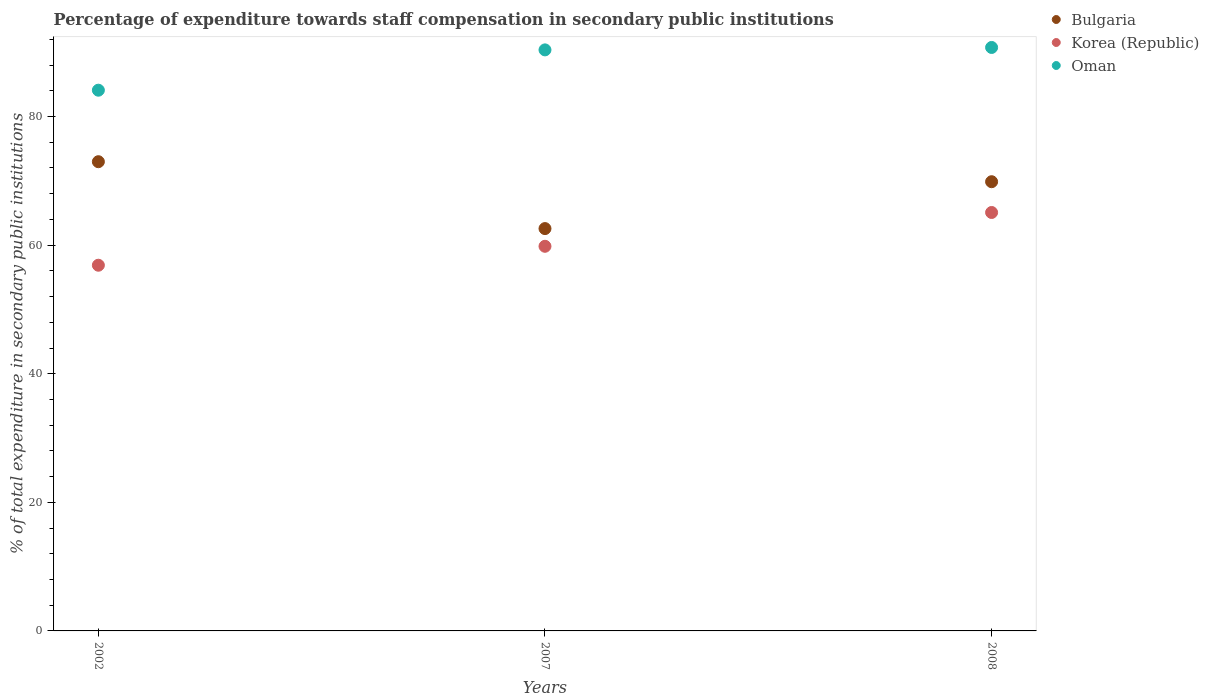How many different coloured dotlines are there?
Your answer should be compact. 3. Is the number of dotlines equal to the number of legend labels?
Provide a succinct answer. Yes. What is the percentage of expenditure towards staff compensation in Korea (Republic) in 2007?
Ensure brevity in your answer.  59.82. Across all years, what is the maximum percentage of expenditure towards staff compensation in Korea (Republic)?
Ensure brevity in your answer.  65.08. Across all years, what is the minimum percentage of expenditure towards staff compensation in Oman?
Make the answer very short. 84.1. What is the total percentage of expenditure towards staff compensation in Bulgaria in the graph?
Provide a short and direct response. 205.41. What is the difference between the percentage of expenditure towards staff compensation in Oman in 2002 and that in 2008?
Keep it short and to the point. -6.65. What is the difference between the percentage of expenditure towards staff compensation in Bulgaria in 2002 and the percentage of expenditure towards staff compensation in Oman in 2007?
Ensure brevity in your answer.  -17.39. What is the average percentage of expenditure towards staff compensation in Oman per year?
Offer a very short reply. 88.4. In the year 2008, what is the difference between the percentage of expenditure towards staff compensation in Oman and percentage of expenditure towards staff compensation in Korea (Republic)?
Your answer should be very brief. 25.67. What is the ratio of the percentage of expenditure towards staff compensation in Korea (Republic) in 2007 to that in 2008?
Ensure brevity in your answer.  0.92. What is the difference between the highest and the second highest percentage of expenditure towards staff compensation in Oman?
Provide a short and direct response. 0.38. What is the difference between the highest and the lowest percentage of expenditure towards staff compensation in Bulgaria?
Your answer should be compact. 10.4. Does the percentage of expenditure towards staff compensation in Bulgaria monotonically increase over the years?
Ensure brevity in your answer.  No. Is the percentage of expenditure towards staff compensation in Bulgaria strictly less than the percentage of expenditure towards staff compensation in Korea (Republic) over the years?
Keep it short and to the point. No. How many years are there in the graph?
Your answer should be very brief. 3. Are the values on the major ticks of Y-axis written in scientific E-notation?
Your answer should be very brief. No. How are the legend labels stacked?
Give a very brief answer. Vertical. What is the title of the graph?
Provide a succinct answer. Percentage of expenditure towards staff compensation in secondary public institutions. Does "Iran" appear as one of the legend labels in the graph?
Provide a succinct answer. No. What is the label or title of the X-axis?
Ensure brevity in your answer.  Years. What is the label or title of the Y-axis?
Offer a very short reply. % of total expenditure in secondary public institutions. What is the % of total expenditure in secondary public institutions of Bulgaria in 2002?
Offer a terse response. 72.97. What is the % of total expenditure in secondary public institutions in Korea (Republic) in 2002?
Ensure brevity in your answer.  56.87. What is the % of total expenditure in secondary public institutions in Oman in 2002?
Provide a succinct answer. 84.1. What is the % of total expenditure in secondary public institutions in Bulgaria in 2007?
Provide a short and direct response. 62.57. What is the % of total expenditure in secondary public institutions in Korea (Republic) in 2007?
Provide a short and direct response. 59.82. What is the % of total expenditure in secondary public institutions in Oman in 2007?
Your answer should be compact. 90.37. What is the % of total expenditure in secondary public institutions in Bulgaria in 2008?
Provide a short and direct response. 69.86. What is the % of total expenditure in secondary public institutions in Korea (Republic) in 2008?
Make the answer very short. 65.08. What is the % of total expenditure in secondary public institutions in Oman in 2008?
Give a very brief answer. 90.74. Across all years, what is the maximum % of total expenditure in secondary public institutions of Bulgaria?
Make the answer very short. 72.97. Across all years, what is the maximum % of total expenditure in secondary public institutions in Korea (Republic)?
Ensure brevity in your answer.  65.08. Across all years, what is the maximum % of total expenditure in secondary public institutions of Oman?
Your answer should be compact. 90.74. Across all years, what is the minimum % of total expenditure in secondary public institutions in Bulgaria?
Offer a terse response. 62.57. Across all years, what is the minimum % of total expenditure in secondary public institutions of Korea (Republic)?
Offer a very short reply. 56.87. Across all years, what is the minimum % of total expenditure in secondary public institutions in Oman?
Provide a succinct answer. 84.1. What is the total % of total expenditure in secondary public institutions of Bulgaria in the graph?
Your response must be concise. 205.41. What is the total % of total expenditure in secondary public institutions in Korea (Republic) in the graph?
Make the answer very short. 181.77. What is the total % of total expenditure in secondary public institutions of Oman in the graph?
Provide a short and direct response. 265.2. What is the difference between the % of total expenditure in secondary public institutions in Bulgaria in 2002 and that in 2007?
Offer a very short reply. 10.4. What is the difference between the % of total expenditure in secondary public institutions in Korea (Republic) in 2002 and that in 2007?
Offer a terse response. -2.94. What is the difference between the % of total expenditure in secondary public institutions of Oman in 2002 and that in 2007?
Offer a very short reply. -6.27. What is the difference between the % of total expenditure in secondary public institutions in Bulgaria in 2002 and that in 2008?
Make the answer very short. 3.11. What is the difference between the % of total expenditure in secondary public institutions of Korea (Republic) in 2002 and that in 2008?
Provide a succinct answer. -8.2. What is the difference between the % of total expenditure in secondary public institutions in Oman in 2002 and that in 2008?
Give a very brief answer. -6.65. What is the difference between the % of total expenditure in secondary public institutions in Bulgaria in 2007 and that in 2008?
Give a very brief answer. -7.29. What is the difference between the % of total expenditure in secondary public institutions of Korea (Republic) in 2007 and that in 2008?
Keep it short and to the point. -5.26. What is the difference between the % of total expenditure in secondary public institutions in Oman in 2007 and that in 2008?
Your answer should be compact. -0.38. What is the difference between the % of total expenditure in secondary public institutions in Bulgaria in 2002 and the % of total expenditure in secondary public institutions in Korea (Republic) in 2007?
Give a very brief answer. 13.16. What is the difference between the % of total expenditure in secondary public institutions in Bulgaria in 2002 and the % of total expenditure in secondary public institutions in Oman in 2007?
Make the answer very short. -17.39. What is the difference between the % of total expenditure in secondary public institutions in Korea (Republic) in 2002 and the % of total expenditure in secondary public institutions in Oman in 2007?
Your response must be concise. -33.49. What is the difference between the % of total expenditure in secondary public institutions in Bulgaria in 2002 and the % of total expenditure in secondary public institutions in Korea (Republic) in 2008?
Make the answer very short. 7.9. What is the difference between the % of total expenditure in secondary public institutions in Bulgaria in 2002 and the % of total expenditure in secondary public institutions in Oman in 2008?
Keep it short and to the point. -17.77. What is the difference between the % of total expenditure in secondary public institutions of Korea (Republic) in 2002 and the % of total expenditure in secondary public institutions of Oman in 2008?
Your response must be concise. -33.87. What is the difference between the % of total expenditure in secondary public institutions of Bulgaria in 2007 and the % of total expenditure in secondary public institutions of Korea (Republic) in 2008?
Your answer should be very brief. -2.5. What is the difference between the % of total expenditure in secondary public institutions of Bulgaria in 2007 and the % of total expenditure in secondary public institutions of Oman in 2008?
Offer a terse response. -28.17. What is the difference between the % of total expenditure in secondary public institutions in Korea (Republic) in 2007 and the % of total expenditure in secondary public institutions in Oman in 2008?
Your response must be concise. -30.92. What is the average % of total expenditure in secondary public institutions in Bulgaria per year?
Offer a very short reply. 68.47. What is the average % of total expenditure in secondary public institutions in Korea (Republic) per year?
Give a very brief answer. 60.59. What is the average % of total expenditure in secondary public institutions in Oman per year?
Ensure brevity in your answer.  88.4. In the year 2002, what is the difference between the % of total expenditure in secondary public institutions in Bulgaria and % of total expenditure in secondary public institutions in Korea (Republic)?
Ensure brevity in your answer.  16.1. In the year 2002, what is the difference between the % of total expenditure in secondary public institutions of Bulgaria and % of total expenditure in secondary public institutions of Oman?
Offer a very short reply. -11.12. In the year 2002, what is the difference between the % of total expenditure in secondary public institutions of Korea (Republic) and % of total expenditure in secondary public institutions of Oman?
Your answer should be compact. -27.22. In the year 2007, what is the difference between the % of total expenditure in secondary public institutions of Bulgaria and % of total expenditure in secondary public institutions of Korea (Republic)?
Your answer should be very brief. 2.75. In the year 2007, what is the difference between the % of total expenditure in secondary public institutions in Bulgaria and % of total expenditure in secondary public institutions in Oman?
Ensure brevity in your answer.  -27.79. In the year 2007, what is the difference between the % of total expenditure in secondary public institutions of Korea (Republic) and % of total expenditure in secondary public institutions of Oman?
Provide a succinct answer. -30.55. In the year 2008, what is the difference between the % of total expenditure in secondary public institutions of Bulgaria and % of total expenditure in secondary public institutions of Korea (Republic)?
Ensure brevity in your answer.  4.79. In the year 2008, what is the difference between the % of total expenditure in secondary public institutions in Bulgaria and % of total expenditure in secondary public institutions in Oman?
Keep it short and to the point. -20.88. In the year 2008, what is the difference between the % of total expenditure in secondary public institutions of Korea (Republic) and % of total expenditure in secondary public institutions of Oman?
Provide a succinct answer. -25.66. What is the ratio of the % of total expenditure in secondary public institutions in Bulgaria in 2002 to that in 2007?
Keep it short and to the point. 1.17. What is the ratio of the % of total expenditure in secondary public institutions in Korea (Republic) in 2002 to that in 2007?
Make the answer very short. 0.95. What is the ratio of the % of total expenditure in secondary public institutions in Oman in 2002 to that in 2007?
Ensure brevity in your answer.  0.93. What is the ratio of the % of total expenditure in secondary public institutions of Bulgaria in 2002 to that in 2008?
Provide a short and direct response. 1.04. What is the ratio of the % of total expenditure in secondary public institutions of Korea (Republic) in 2002 to that in 2008?
Ensure brevity in your answer.  0.87. What is the ratio of the % of total expenditure in secondary public institutions of Oman in 2002 to that in 2008?
Your response must be concise. 0.93. What is the ratio of the % of total expenditure in secondary public institutions of Bulgaria in 2007 to that in 2008?
Give a very brief answer. 0.9. What is the ratio of the % of total expenditure in secondary public institutions in Korea (Republic) in 2007 to that in 2008?
Your answer should be compact. 0.92. What is the ratio of the % of total expenditure in secondary public institutions of Oman in 2007 to that in 2008?
Make the answer very short. 1. What is the difference between the highest and the second highest % of total expenditure in secondary public institutions in Bulgaria?
Offer a terse response. 3.11. What is the difference between the highest and the second highest % of total expenditure in secondary public institutions of Korea (Republic)?
Give a very brief answer. 5.26. What is the difference between the highest and the second highest % of total expenditure in secondary public institutions of Oman?
Your response must be concise. 0.38. What is the difference between the highest and the lowest % of total expenditure in secondary public institutions of Bulgaria?
Offer a very short reply. 10.4. What is the difference between the highest and the lowest % of total expenditure in secondary public institutions of Korea (Republic)?
Ensure brevity in your answer.  8.2. What is the difference between the highest and the lowest % of total expenditure in secondary public institutions of Oman?
Give a very brief answer. 6.65. 